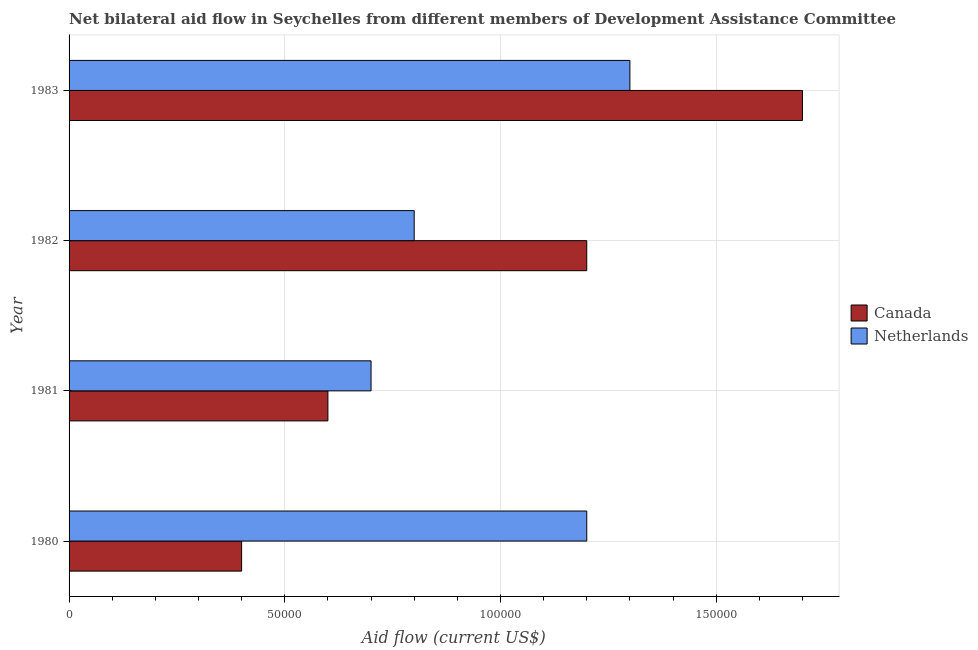How many bars are there on the 4th tick from the bottom?
Your answer should be compact. 2. What is the label of the 2nd group of bars from the top?
Offer a very short reply. 1982. In how many cases, is the number of bars for a given year not equal to the number of legend labels?
Provide a short and direct response. 0. What is the amount of aid given by netherlands in 1982?
Your response must be concise. 8.00e+04. Across all years, what is the maximum amount of aid given by canada?
Your answer should be compact. 1.70e+05. Across all years, what is the minimum amount of aid given by canada?
Offer a very short reply. 4.00e+04. In which year was the amount of aid given by netherlands maximum?
Your answer should be compact. 1983. In which year was the amount of aid given by canada minimum?
Your answer should be very brief. 1980. What is the total amount of aid given by netherlands in the graph?
Offer a very short reply. 4.00e+05. What is the difference between the amount of aid given by canada in 1981 and that in 1982?
Provide a short and direct response. -6.00e+04. What is the difference between the amount of aid given by canada in 1982 and the amount of aid given by netherlands in 1981?
Keep it short and to the point. 5.00e+04. What is the average amount of aid given by netherlands per year?
Keep it short and to the point. 1.00e+05. In the year 1980, what is the difference between the amount of aid given by netherlands and amount of aid given by canada?
Keep it short and to the point. 8.00e+04. In how many years, is the amount of aid given by netherlands greater than 10000 US$?
Offer a very short reply. 4. What is the ratio of the amount of aid given by canada in 1980 to that in 1982?
Provide a succinct answer. 0.33. What is the difference between the highest and the lowest amount of aid given by canada?
Make the answer very short. 1.30e+05. In how many years, is the amount of aid given by netherlands greater than the average amount of aid given by netherlands taken over all years?
Give a very brief answer. 2. Is the sum of the amount of aid given by netherlands in 1981 and 1982 greater than the maximum amount of aid given by canada across all years?
Offer a very short reply. No. What does the 2nd bar from the top in 1980 represents?
Your response must be concise. Canada. Are all the bars in the graph horizontal?
Ensure brevity in your answer.  Yes. Does the graph contain any zero values?
Offer a very short reply. No. Does the graph contain grids?
Give a very brief answer. Yes. How many legend labels are there?
Your answer should be compact. 2. What is the title of the graph?
Offer a terse response. Net bilateral aid flow in Seychelles from different members of Development Assistance Committee. What is the label or title of the Y-axis?
Make the answer very short. Year. What is the Aid flow (current US$) in Canada in 1981?
Your answer should be compact. 6.00e+04. What is the Aid flow (current US$) of Canada in 1982?
Offer a very short reply. 1.20e+05. What is the Aid flow (current US$) in Netherlands in 1982?
Offer a terse response. 8.00e+04. What is the Aid flow (current US$) in Canada in 1983?
Offer a terse response. 1.70e+05. Across all years, what is the maximum Aid flow (current US$) of Canada?
Your answer should be very brief. 1.70e+05. Across all years, what is the minimum Aid flow (current US$) in Canada?
Provide a succinct answer. 4.00e+04. Across all years, what is the minimum Aid flow (current US$) in Netherlands?
Your answer should be very brief. 7.00e+04. What is the difference between the Aid flow (current US$) in Canada in 1980 and that in 1981?
Keep it short and to the point. -2.00e+04. What is the difference between the Aid flow (current US$) of Netherlands in 1980 and that in 1981?
Make the answer very short. 5.00e+04. What is the difference between the Aid flow (current US$) of Canada in 1980 and that in 1982?
Offer a terse response. -8.00e+04. What is the difference between the Aid flow (current US$) in Canada in 1980 and that in 1983?
Keep it short and to the point. -1.30e+05. What is the difference between the Aid flow (current US$) of Netherlands in 1980 and that in 1983?
Keep it short and to the point. -10000. What is the difference between the Aid flow (current US$) in Netherlands in 1982 and that in 1983?
Make the answer very short. -5.00e+04. What is the difference between the Aid flow (current US$) in Canada in 1980 and the Aid flow (current US$) in Netherlands in 1983?
Provide a short and direct response. -9.00e+04. What is the difference between the Aid flow (current US$) in Canada in 1981 and the Aid flow (current US$) in Netherlands in 1983?
Offer a very short reply. -7.00e+04. What is the difference between the Aid flow (current US$) of Canada in 1982 and the Aid flow (current US$) of Netherlands in 1983?
Offer a very short reply. -10000. What is the average Aid flow (current US$) of Canada per year?
Make the answer very short. 9.75e+04. What is the average Aid flow (current US$) of Netherlands per year?
Offer a terse response. 1.00e+05. What is the ratio of the Aid flow (current US$) of Netherlands in 1980 to that in 1981?
Give a very brief answer. 1.71. What is the ratio of the Aid flow (current US$) in Canada in 1980 to that in 1983?
Give a very brief answer. 0.24. What is the ratio of the Aid flow (current US$) in Netherlands in 1980 to that in 1983?
Your response must be concise. 0.92. What is the ratio of the Aid flow (current US$) in Canada in 1981 to that in 1982?
Provide a short and direct response. 0.5. What is the ratio of the Aid flow (current US$) of Netherlands in 1981 to that in 1982?
Your answer should be very brief. 0.88. What is the ratio of the Aid flow (current US$) in Canada in 1981 to that in 1983?
Offer a terse response. 0.35. What is the ratio of the Aid flow (current US$) in Netherlands in 1981 to that in 1983?
Provide a succinct answer. 0.54. What is the ratio of the Aid flow (current US$) in Canada in 1982 to that in 1983?
Your response must be concise. 0.71. What is the ratio of the Aid flow (current US$) in Netherlands in 1982 to that in 1983?
Provide a succinct answer. 0.62. What is the difference between the highest and the second highest Aid flow (current US$) of Canada?
Provide a short and direct response. 5.00e+04. What is the difference between the highest and the lowest Aid flow (current US$) in Netherlands?
Offer a very short reply. 6.00e+04. 